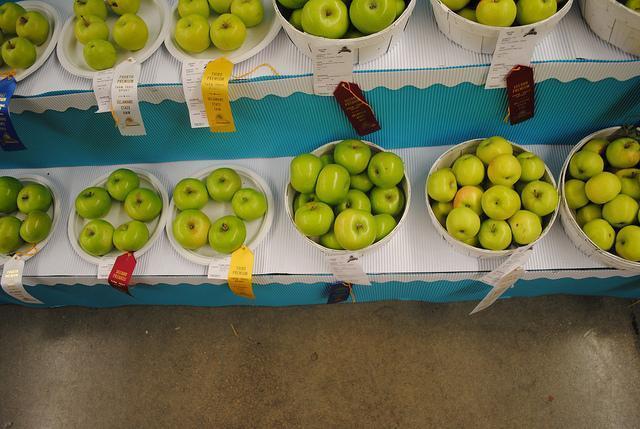How many apples are in the plate with the yellow ribbon?
Give a very brief answer. 5. How many ribbons are on display?
Give a very brief answer. 10. How many bowls can be seen?
Give a very brief answer. 6. How many apples are visible?
Give a very brief answer. 5. 